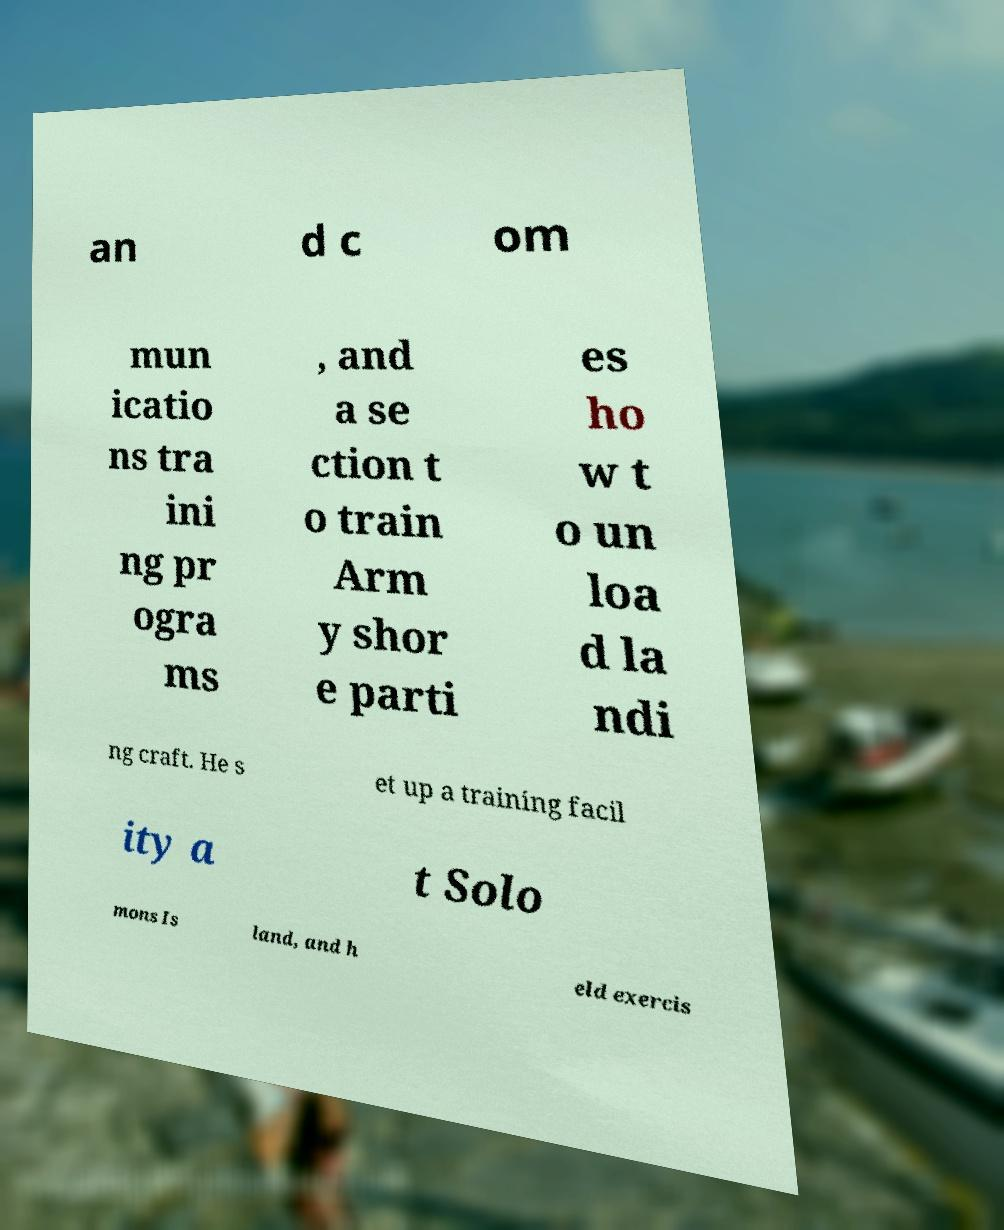Please identify and transcribe the text found in this image. an d c om mun icatio ns tra ini ng pr ogra ms , and a se ction t o train Arm y shor e parti es ho w t o un loa d la ndi ng craft. He s et up a training facil ity a t Solo mons Is land, and h eld exercis 